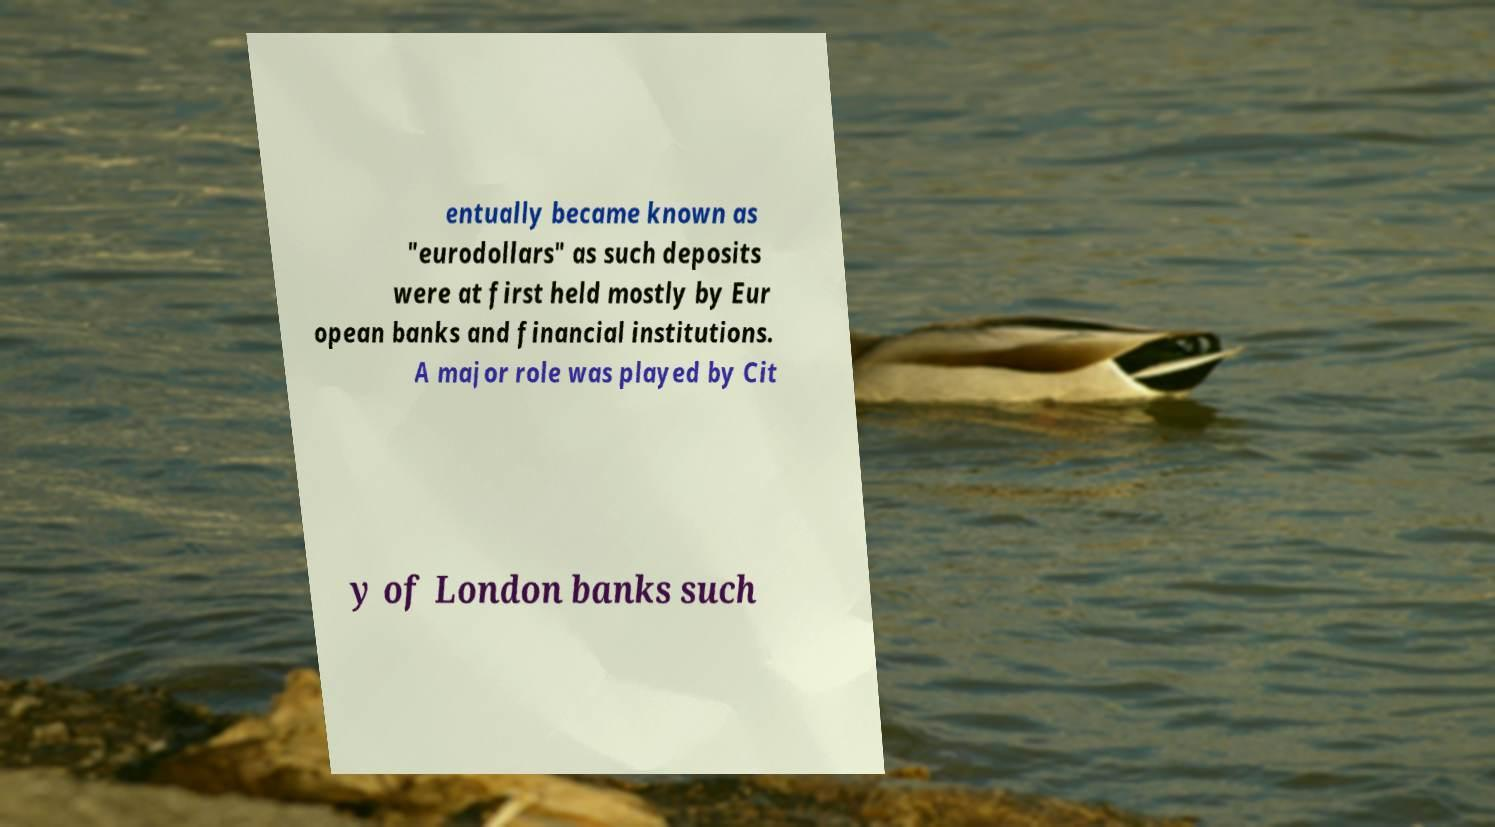What messages or text are displayed in this image? I need them in a readable, typed format. entually became known as "eurodollars" as such deposits were at first held mostly by Eur opean banks and financial institutions. A major role was played by Cit y of London banks such 